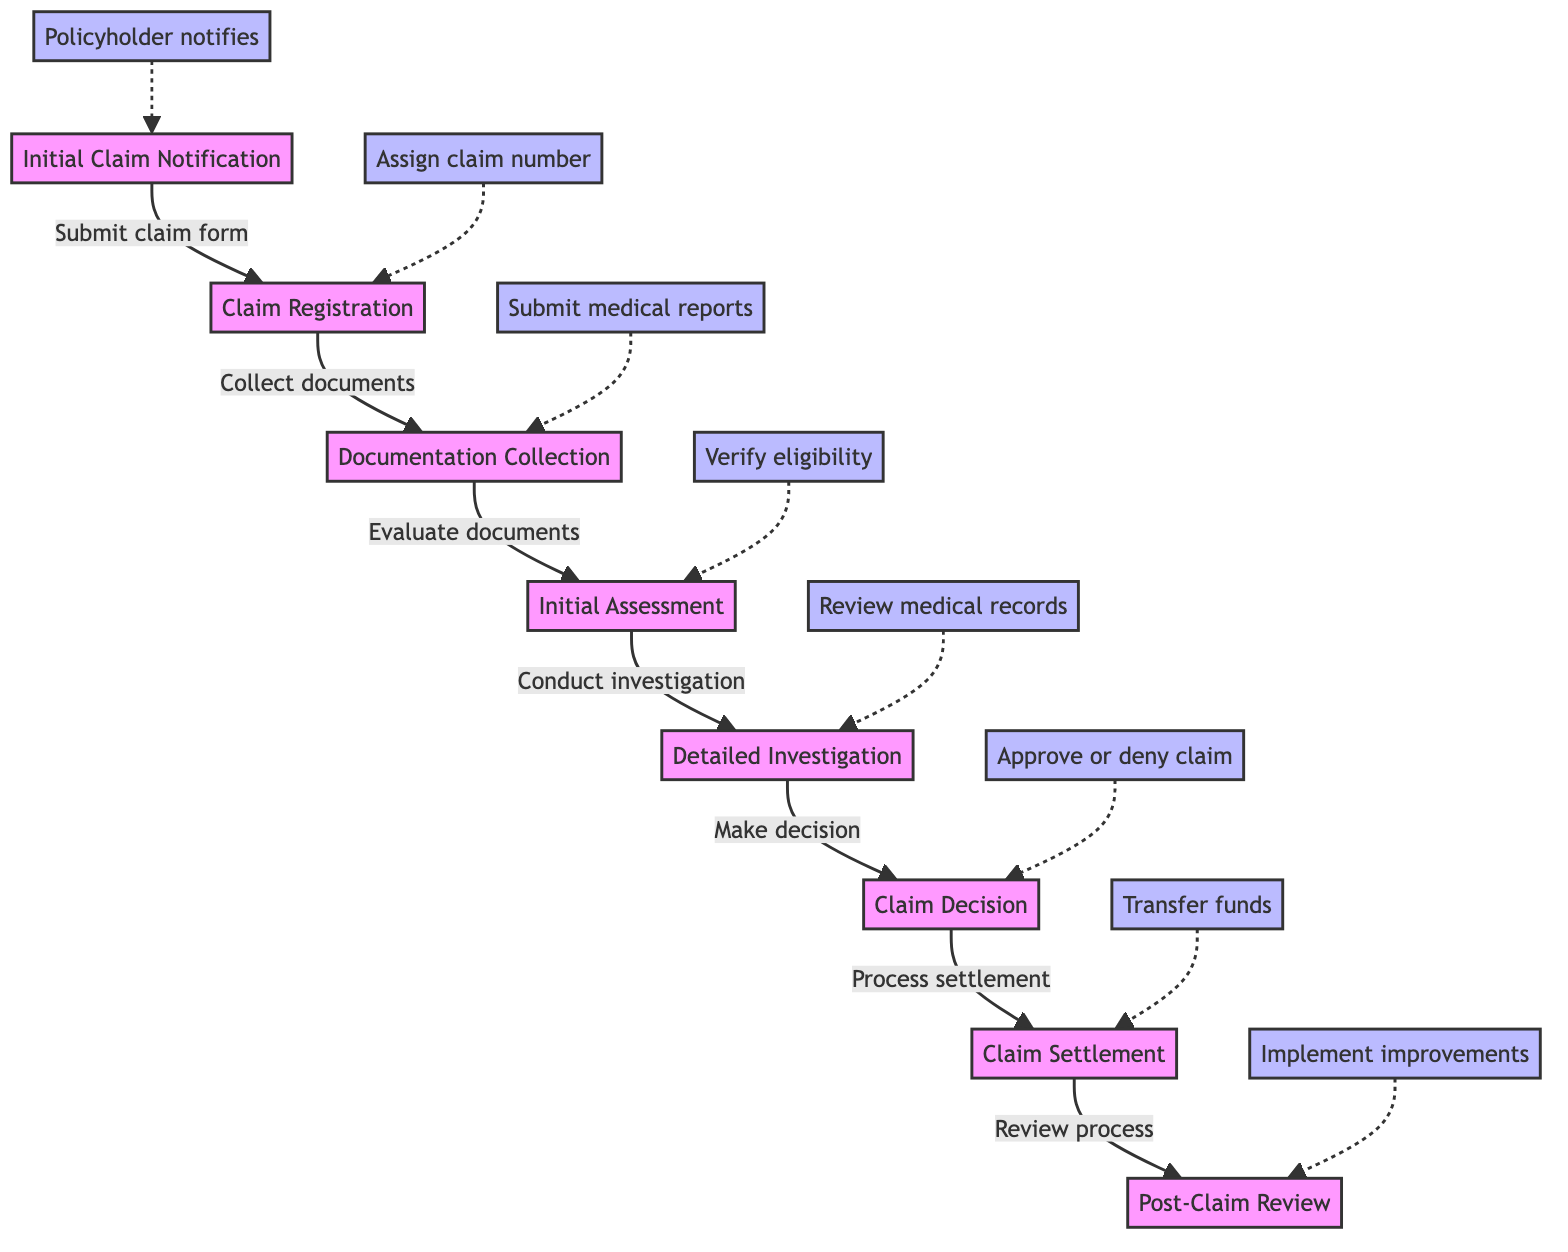What is the first step in the claims management process? The first step indicated in the diagram is "Initial Claim Notification," where the policyholder notifies the insurance provider about the health incident.
Answer: Initial Claim Notification How many steps are there in the claims management process? The diagram shows a total of eight distinct steps, illustrating the full flow of claims management from initial notification to post-claim review.
Answer: 8 Which entity is involved in the documentation collection step? The document collection step involves both the policyholder and medical providers, as they contribute necessary documents to support the claim.
Answer: Policyholder, Medical Providers What is the outcome of the claim decision? The outcome of the claim decision is either to approve, deny, or partially approve the claim, based on the investigation findings.
Answer: Approve, deny, or partially approve What action follows the detailed investigation step? The action that immediately follows the detailed investigation step is to make a decision regarding the claim, determining whether it is valid or not.
Answer: Make decision Which step involves the transfer of funds? The step that involves the transfer of funds occurs during the claim settlement phase, where the insurance provider processes the settlement amount for the approved claim.
Answer: Claim Settlement What key entities are involved in the initial assessment and verification? The key entities involved in the initial assessment and verification step include the insurance provider and the risk management consultant, who work to evaluate the submitted documents and verify eligibility.
Answer: Insurance Provider, Risk Management Consultant During which step is the claim number assigned? The claim number is assigned during the claim registration step, which is the second step in the claims management process.
Answer: Claim Registration 